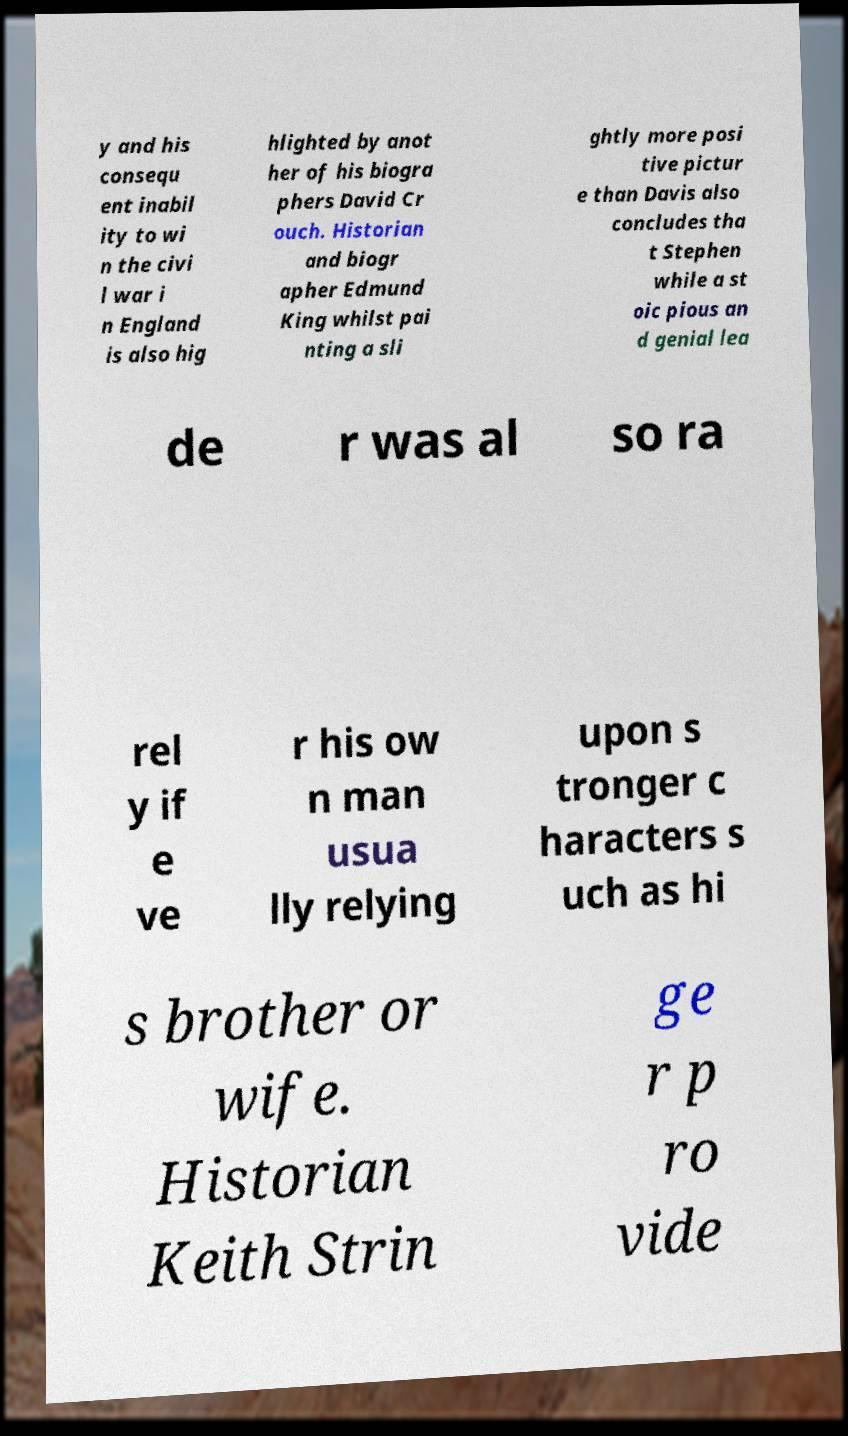Please identify and transcribe the text found in this image. y and his consequ ent inabil ity to wi n the civi l war i n England is also hig hlighted by anot her of his biogra phers David Cr ouch. Historian and biogr apher Edmund King whilst pai nting a sli ghtly more posi tive pictur e than Davis also concludes tha t Stephen while a st oic pious an d genial lea de r was al so ra rel y if e ve r his ow n man usua lly relying upon s tronger c haracters s uch as hi s brother or wife. Historian Keith Strin ge r p ro vide 